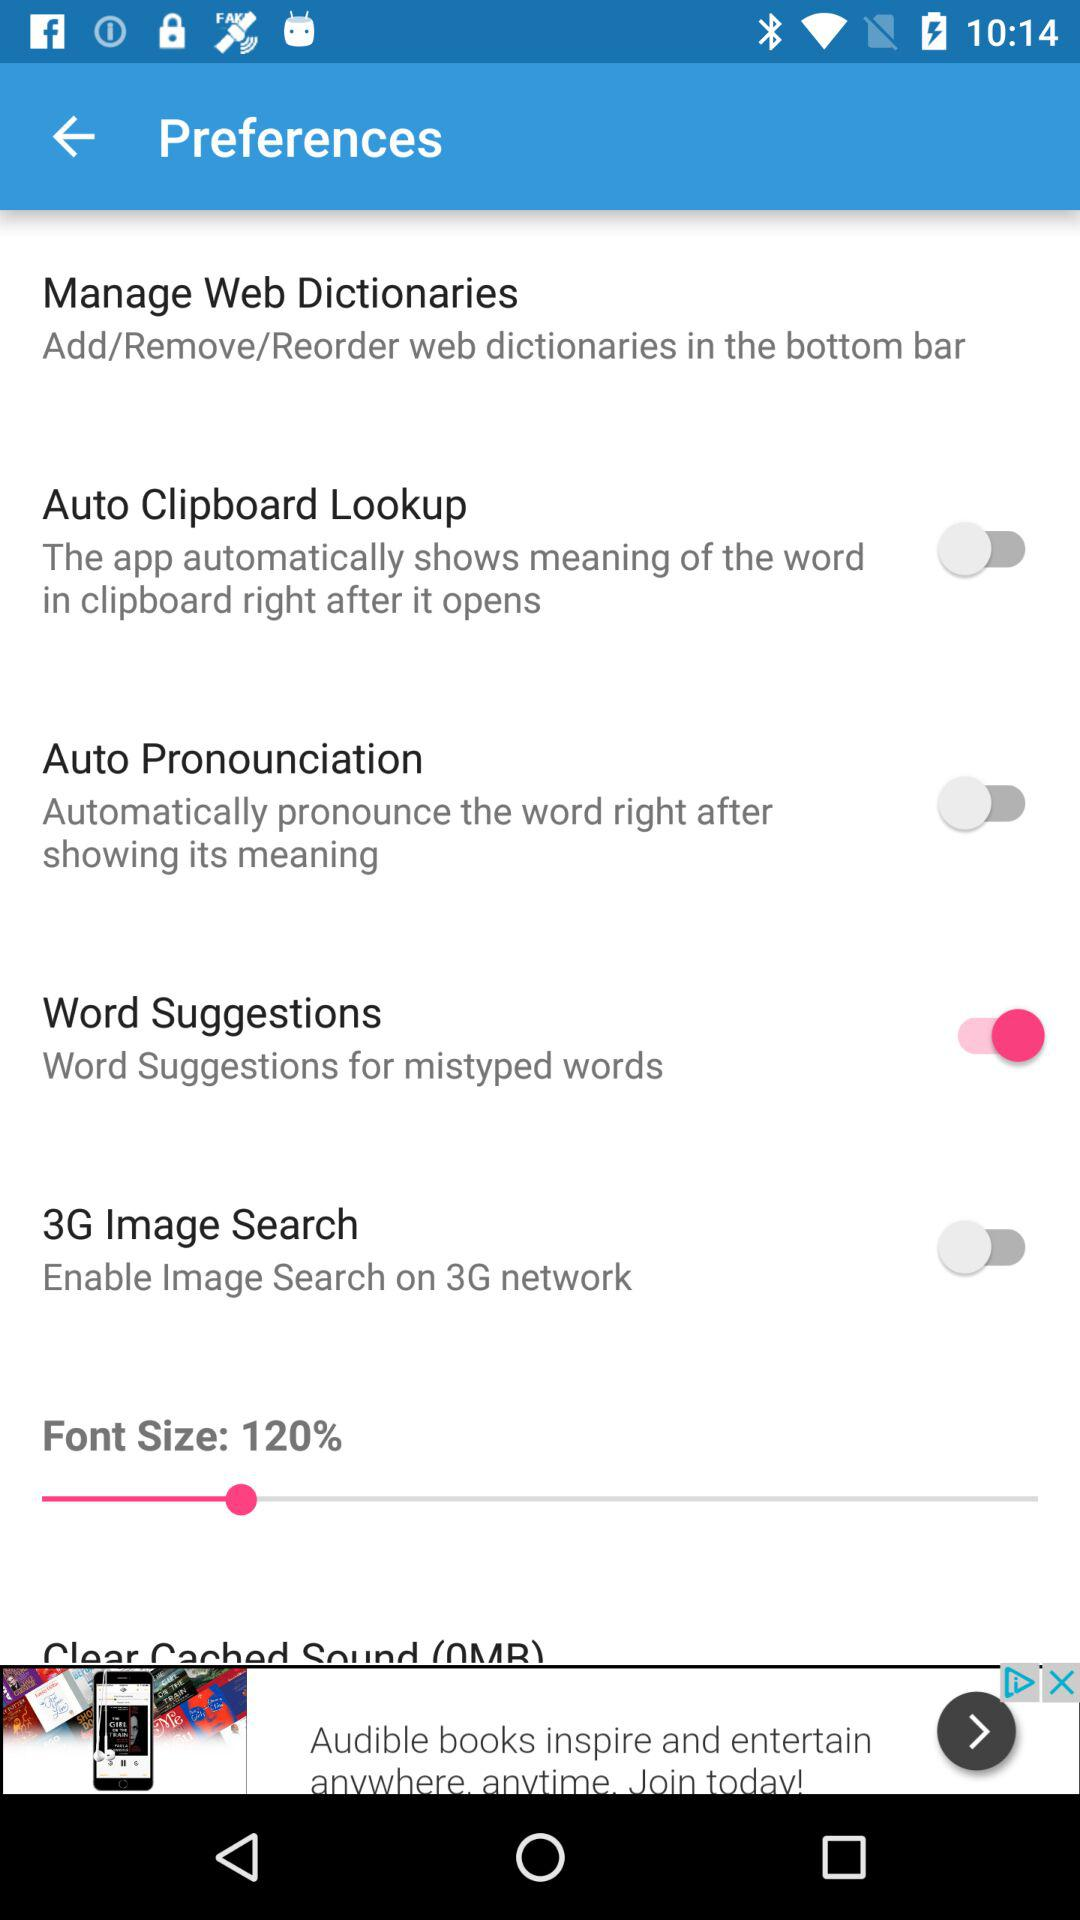How much percentage is selected for font size? The selected percentage is 120. 